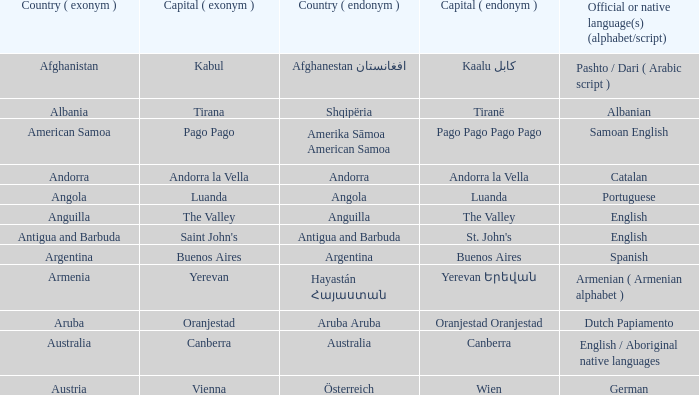What is the english moniker for the country where dutch papiamento is the formal indigenous language? Aruba. 